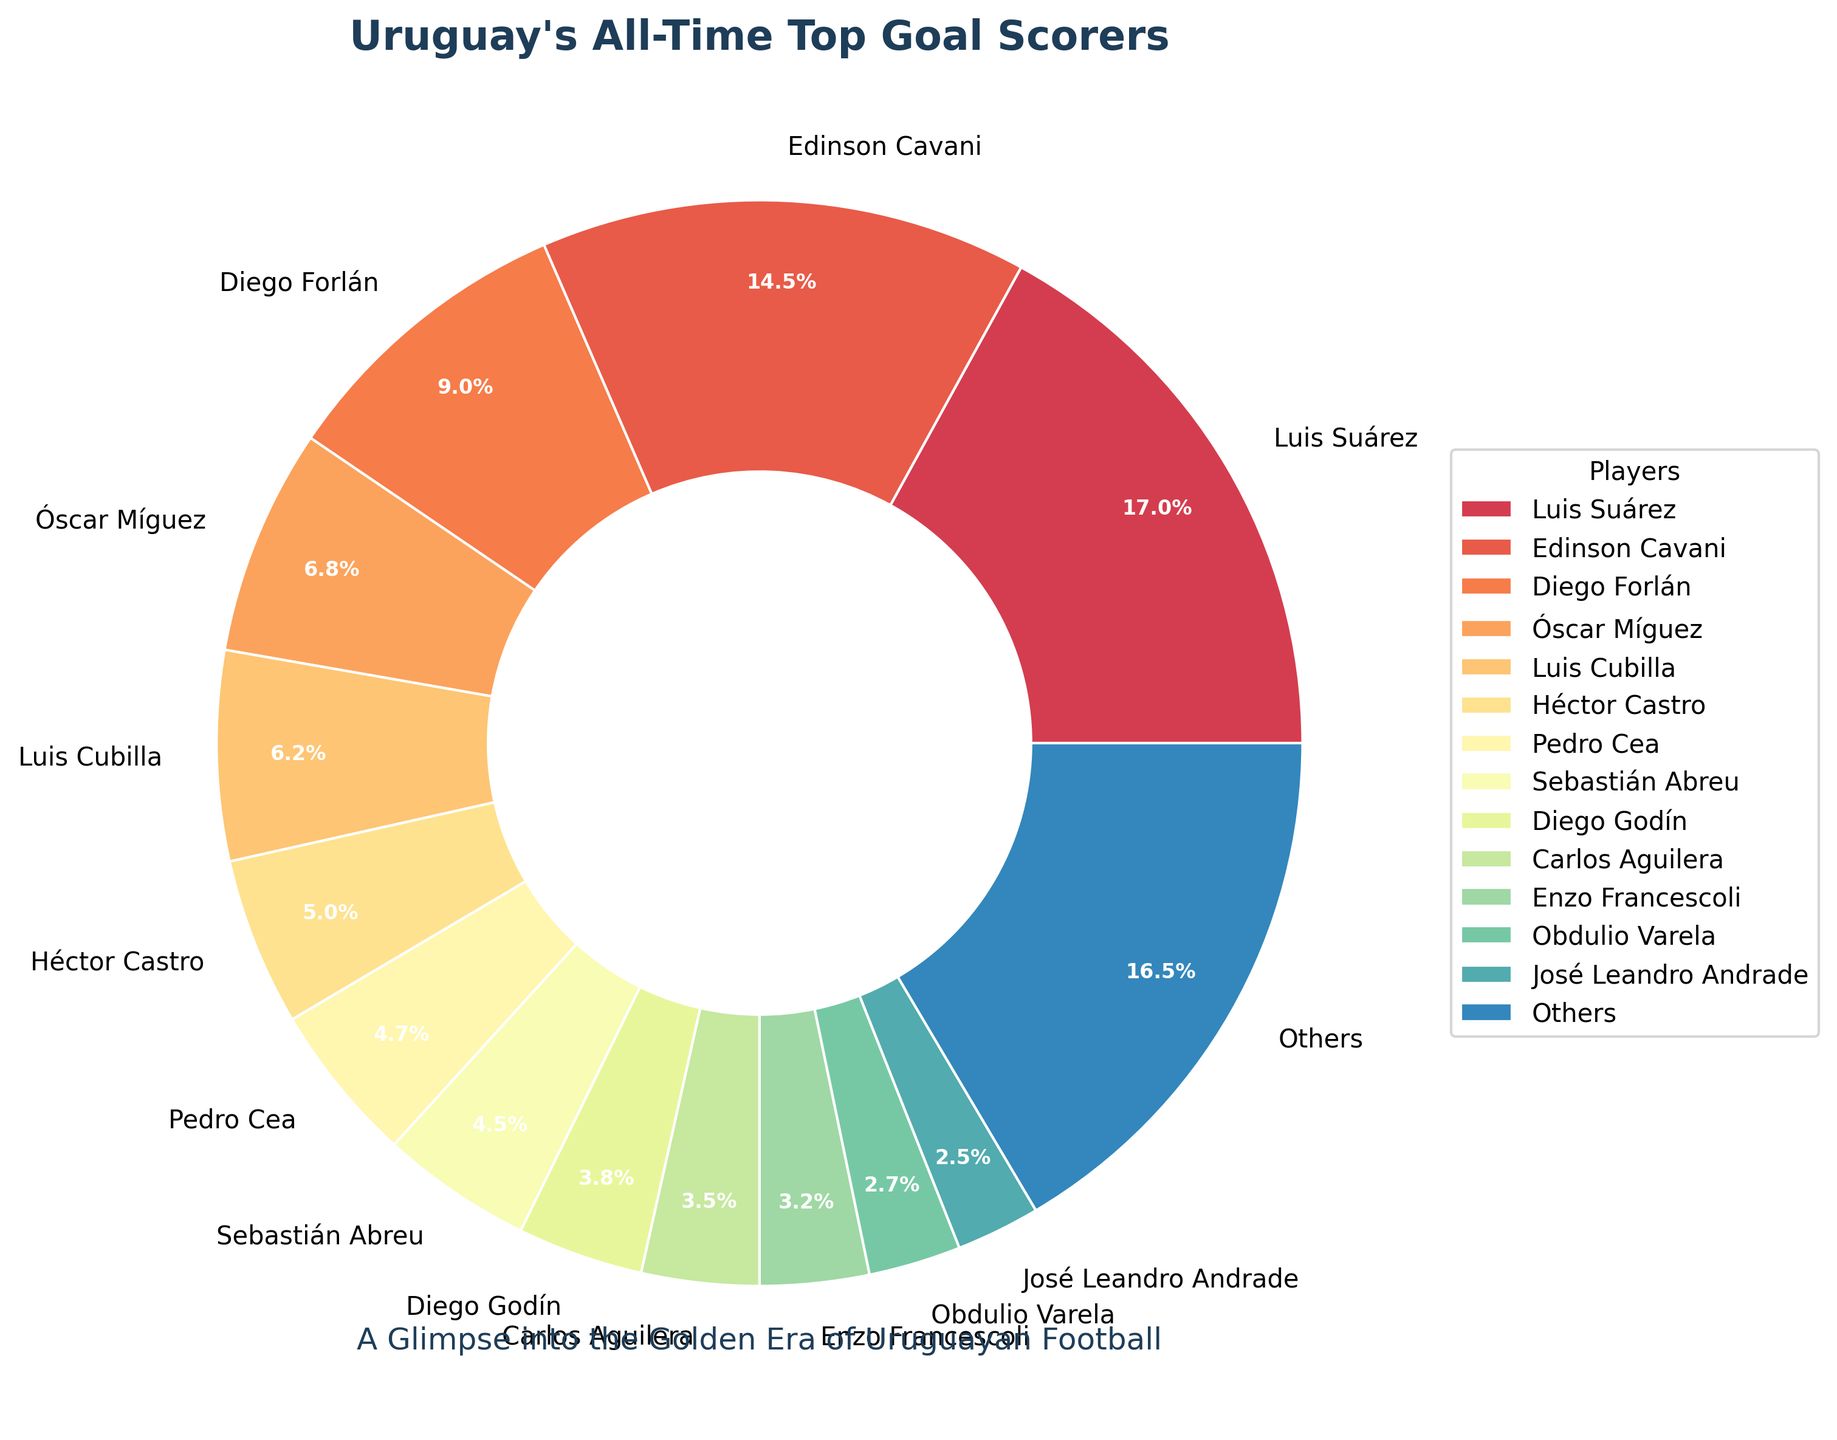Which player has scored the most goals for Uruguay? Luis Suárez has scored the most goals for Uruguay with a total of 68 goals. This can be observed directly from the chart where Luis Suárez's segment is the largest.
Answer: Luis Suárez What percentage of the total goals are made by Luis Suárez and Edinson Cavani together? According to the chart, Luis Suárez has 68 goals and Edinson Cavani has 58 goals. Add these two values to get the total: 68 + 58 = 126. The total number of goals in the chart sums up to 340 (calculated from all segments). The percentage is calculated by (126/340) * 100 ≈ 37.1%.
Answer: 37.1% How many more goals has Diego Forlán scored compared to Héctor Castro? Diego Forlán has scored 36 goals while Héctor Castro has scored 20 goals. Subtract the two values: 36 - 20 = 16.
Answer: 16 Compare the goals scored by Diego Godín and Carlos Aguilera. Who has scored more and by how much? Diego Godín has 15 goals, and Carlos Aguilera has 14 goals. Diego Godín has scored more goals, with a difference of 15 - 14 = 1.
Answer: Diego Godín by 1 What is the combined total of goals scored by the three players with the fewest goals shown individually? The three players with the fewest goals shown individually are José Leandro Andrade (10), Obdulio Varela (11), and Enzo Francescoli (13). Adding their goals: 10 + 11 + 13 = 34.
Answer: 34 Which player has a similar number of goals to Luis Cubilla, and how many goals does that player have? Luis Cubilla has scored 25 goals, and the closest player to this number is Óscar Míguez with 27 goals.
Answer: Óscar Míguez with 27 goals How does the segment representing "Others" compare in size to the segment representing Diego Forlán in terms of goals? The "Others" segment represents 66 goals, whereas Diego Forlán has scored 36 goals. The difference in size is 66 - 36 = 30 goals.
Answer: 30 more goals for "Others" Who are the top three goal scorers, and what is their combined goal total? The top three goal scorers are Luis Suárez (68), Edinson Cavani (58), and Diego Forlán (36). The combined total is 68 + 58 + 36 = 162.
Answer: 162 